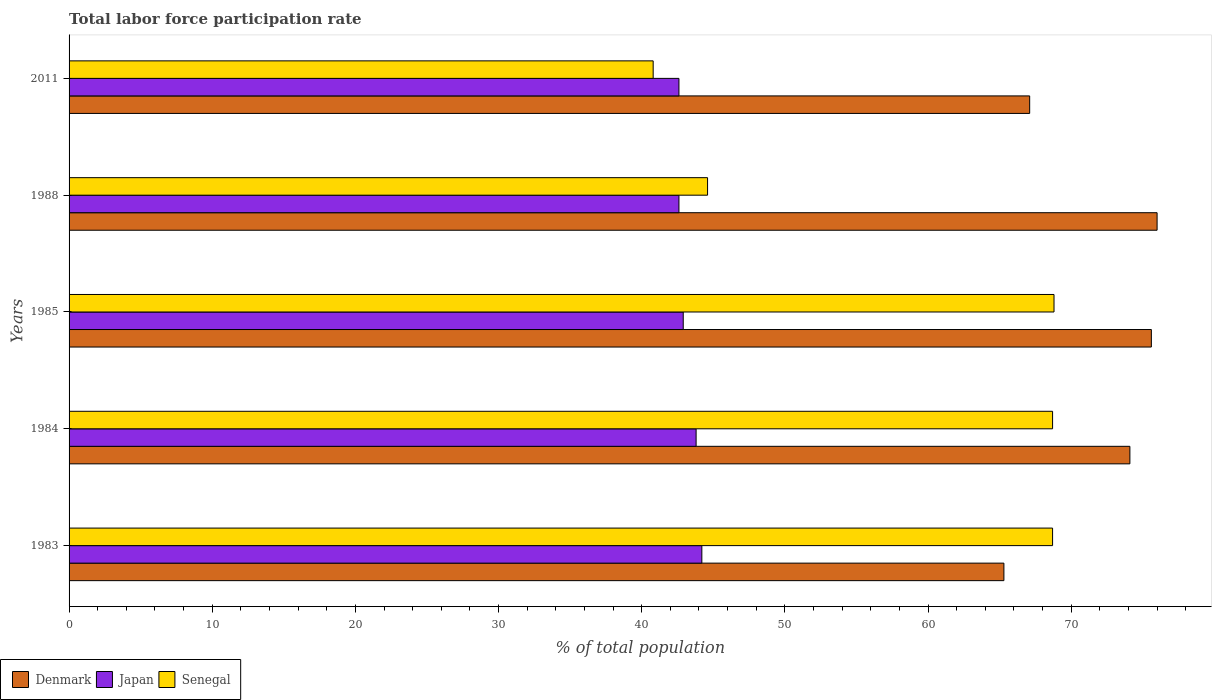How many groups of bars are there?
Your answer should be very brief. 5. Are the number of bars per tick equal to the number of legend labels?
Ensure brevity in your answer.  Yes. Are the number of bars on each tick of the Y-axis equal?
Give a very brief answer. Yes. What is the label of the 5th group of bars from the top?
Give a very brief answer. 1983. In how many cases, is the number of bars for a given year not equal to the number of legend labels?
Keep it short and to the point. 0. What is the total labor force participation rate in Japan in 1985?
Give a very brief answer. 42.9. Across all years, what is the maximum total labor force participation rate in Denmark?
Your answer should be compact. 76. Across all years, what is the minimum total labor force participation rate in Denmark?
Provide a succinct answer. 65.3. In which year was the total labor force participation rate in Japan minimum?
Provide a short and direct response. 1988. What is the total total labor force participation rate in Senegal in the graph?
Offer a terse response. 291.6. What is the difference between the total labor force participation rate in Senegal in 1984 and that in 1985?
Offer a very short reply. -0.1. What is the difference between the total labor force participation rate in Japan in 1983 and the total labor force participation rate in Denmark in 1984?
Ensure brevity in your answer.  -29.9. What is the average total labor force participation rate in Japan per year?
Provide a short and direct response. 43.22. In the year 1988, what is the difference between the total labor force participation rate in Denmark and total labor force participation rate in Japan?
Your answer should be very brief. 33.4. What is the ratio of the total labor force participation rate in Senegal in 1983 to that in 2011?
Provide a short and direct response. 1.68. Is the total labor force participation rate in Senegal in 1983 less than that in 1985?
Offer a very short reply. Yes. What is the difference between the highest and the second highest total labor force participation rate in Denmark?
Make the answer very short. 0.4. What is the difference between the highest and the lowest total labor force participation rate in Senegal?
Your response must be concise. 28. What does the 1st bar from the top in 1985 represents?
Offer a very short reply. Senegal. What does the 1st bar from the bottom in 2011 represents?
Offer a terse response. Denmark. How many years are there in the graph?
Your answer should be very brief. 5. Are the values on the major ticks of X-axis written in scientific E-notation?
Your response must be concise. No. Does the graph contain any zero values?
Offer a terse response. No. Where does the legend appear in the graph?
Keep it short and to the point. Bottom left. How are the legend labels stacked?
Offer a very short reply. Horizontal. What is the title of the graph?
Offer a very short reply. Total labor force participation rate. What is the label or title of the X-axis?
Give a very brief answer. % of total population. What is the % of total population in Denmark in 1983?
Offer a very short reply. 65.3. What is the % of total population of Japan in 1983?
Provide a short and direct response. 44.2. What is the % of total population of Senegal in 1983?
Provide a succinct answer. 68.7. What is the % of total population in Denmark in 1984?
Your answer should be very brief. 74.1. What is the % of total population in Japan in 1984?
Your response must be concise. 43.8. What is the % of total population in Senegal in 1984?
Your answer should be very brief. 68.7. What is the % of total population in Denmark in 1985?
Your response must be concise. 75.6. What is the % of total population of Japan in 1985?
Make the answer very short. 42.9. What is the % of total population of Senegal in 1985?
Ensure brevity in your answer.  68.8. What is the % of total population in Japan in 1988?
Your response must be concise. 42.6. What is the % of total population in Senegal in 1988?
Offer a terse response. 44.6. What is the % of total population in Denmark in 2011?
Offer a terse response. 67.1. What is the % of total population in Japan in 2011?
Provide a short and direct response. 42.6. What is the % of total population in Senegal in 2011?
Provide a succinct answer. 40.8. Across all years, what is the maximum % of total population in Japan?
Provide a succinct answer. 44.2. Across all years, what is the maximum % of total population of Senegal?
Provide a short and direct response. 68.8. Across all years, what is the minimum % of total population of Denmark?
Offer a terse response. 65.3. Across all years, what is the minimum % of total population of Japan?
Provide a short and direct response. 42.6. Across all years, what is the minimum % of total population of Senegal?
Offer a very short reply. 40.8. What is the total % of total population of Denmark in the graph?
Offer a terse response. 358.1. What is the total % of total population in Japan in the graph?
Keep it short and to the point. 216.1. What is the total % of total population in Senegal in the graph?
Make the answer very short. 291.6. What is the difference between the % of total population of Japan in 1983 and that in 1984?
Give a very brief answer. 0.4. What is the difference between the % of total population in Senegal in 1983 and that in 1984?
Your answer should be very brief. 0. What is the difference between the % of total population of Denmark in 1983 and that in 1985?
Offer a very short reply. -10.3. What is the difference between the % of total population in Japan in 1983 and that in 1985?
Give a very brief answer. 1.3. What is the difference between the % of total population of Senegal in 1983 and that in 1985?
Offer a terse response. -0.1. What is the difference between the % of total population in Denmark in 1983 and that in 1988?
Your answer should be very brief. -10.7. What is the difference between the % of total population of Japan in 1983 and that in 1988?
Provide a short and direct response. 1.6. What is the difference between the % of total population of Senegal in 1983 and that in 1988?
Provide a succinct answer. 24.1. What is the difference between the % of total population of Japan in 1983 and that in 2011?
Offer a very short reply. 1.6. What is the difference between the % of total population in Senegal in 1983 and that in 2011?
Provide a succinct answer. 27.9. What is the difference between the % of total population of Senegal in 1984 and that in 1988?
Make the answer very short. 24.1. What is the difference between the % of total population of Senegal in 1984 and that in 2011?
Provide a succinct answer. 27.9. What is the difference between the % of total population of Denmark in 1985 and that in 1988?
Provide a succinct answer. -0.4. What is the difference between the % of total population in Senegal in 1985 and that in 1988?
Make the answer very short. 24.2. What is the difference between the % of total population of Denmark in 1985 and that in 2011?
Your answer should be very brief. 8.5. What is the difference between the % of total population in Senegal in 1985 and that in 2011?
Ensure brevity in your answer.  28. What is the difference between the % of total population in Senegal in 1988 and that in 2011?
Provide a short and direct response. 3.8. What is the difference between the % of total population of Denmark in 1983 and the % of total population of Senegal in 1984?
Offer a very short reply. -3.4. What is the difference between the % of total population of Japan in 1983 and the % of total population of Senegal in 1984?
Your response must be concise. -24.5. What is the difference between the % of total population in Denmark in 1983 and the % of total population in Japan in 1985?
Give a very brief answer. 22.4. What is the difference between the % of total population in Japan in 1983 and the % of total population in Senegal in 1985?
Your answer should be compact. -24.6. What is the difference between the % of total population in Denmark in 1983 and the % of total population in Japan in 1988?
Ensure brevity in your answer.  22.7. What is the difference between the % of total population of Denmark in 1983 and the % of total population of Senegal in 1988?
Give a very brief answer. 20.7. What is the difference between the % of total population in Denmark in 1983 and the % of total population in Japan in 2011?
Offer a very short reply. 22.7. What is the difference between the % of total population of Denmark in 1984 and the % of total population of Japan in 1985?
Provide a succinct answer. 31.2. What is the difference between the % of total population in Denmark in 1984 and the % of total population in Senegal in 1985?
Keep it short and to the point. 5.3. What is the difference between the % of total population of Japan in 1984 and the % of total population of Senegal in 1985?
Keep it short and to the point. -25. What is the difference between the % of total population of Denmark in 1984 and the % of total population of Japan in 1988?
Provide a succinct answer. 31.5. What is the difference between the % of total population in Denmark in 1984 and the % of total population in Senegal in 1988?
Your response must be concise. 29.5. What is the difference between the % of total population in Japan in 1984 and the % of total population in Senegal in 1988?
Offer a very short reply. -0.8. What is the difference between the % of total population of Denmark in 1984 and the % of total population of Japan in 2011?
Ensure brevity in your answer.  31.5. What is the difference between the % of total population in Denmark in 1984 and the % of total population in Senegal in 2011?
Keep it short and to the point. 33.3. What is the difference between the % of total population of Japan in 1984 and the % of total population of Senegal in 2011?
Your answer should be compact. 3. What is the difference between the % of total population in Denmark in 1985 and the % of total population in Japan in 1988?
Your answer should be compact. 33. What is the difference between the % of total population in Denmark in 1985 and the % of total population in Senegal in 2011?
Offer a very short reply. 34.8. What is the difference between the % of total population in Denmark in 1988 and the % of total population in Japan in 2011?
Provide a short and direct response. 33.4. What is the difference between the % of total population in Denmark in 1988 and the % of total population in Senegal in 2011?
Your response must be concise. 35.2. What is the average % of total population of Denmark per year?
Your answer should be compact. 71.62. What is the average % of total population of Japan per year?
Give a very brief answer. 43.22. What is the average % of total population of Senegal per year?
Make the answer very short. 58.32. In the year 1983, what is the difference between the % of total population in Denmark and % of total population in Japan?
Your answer should be compact. 21.1. In the year 1983, what is the difference between the % of total population in Japan and % of total population in Senegal?
Offer a very short reply. -24.5. In the year 1984, what is the difference between the % of total population of Denmark and % of total population of Japan?
Your response must be concise. 30.3. In the year 1984, what is the difference between the % of total population of Denmark and % of total population of Senegal?
Provide a succinct answer. 5.4. In the year 1984, what is the difference between the % of total population in Japan and % of total population in Senegal?
Ensure brevity in your answer.  -24.9. In the year 1985, what is the difference between the % of total population in Denmark and % of total population in Japan?
Offer a terse response. 32.7. In the year 1985, what is the difference between the % of total population in Denmark and % of total population in Senegal?
Ensure brevity in your answer.  6.8. In the year 1985, what is the difference between the % of total population in Japan and % of total population in Senegal?
Make the answer very short. -25.9. In the year 1988, what is the difference between the % of total population of Denmark and % of total population of Japan?
Offer a very short reply. 33.4. In the year 1988, what is the difference between the % of total population of Denmark and % of total population of Senegal?
Provide a succinct answer. 31.4. In the year 2011, what is the difference between the % of total population in Denmark and % of total population in Senegal?
Your answer should be very brief. 26.3. In the year 2011, what is the difference between the % of total population in Japan and % of total population in Senegal?
Ensure brevity in your answer.  1.8. What is the ratio of the % of total population of Denmark in 1983 to that in 1984?
Provide a short and direct response. 0.88. What is the ratio of the % of total population of Japan in 1983 to that in 1984?
Offer a terse response. 1.01. What is the ratio of the % of total population of Senegal in 1983 to that in 1984?
Your response must be concise. 1. What is the ratio of the % of total population of Denmark in 1983 to that in 1985?
Your answer should be very brief. 0.86. What is the ratio of the % of total population of Japan in 1983 to that in 1985?
Give a very brief answer. 1.03. What is the ratio of the % of total population of Senegal in 1983 to that in 1985?
Ensure brevity in your answer.  1. What is the ratio of the % of total population of Denmark in 1983 to that in 1988?
Ensure brevity in your answer.  0.86. What is the ratio of the % of total population in Japan in 1983 to that in 1988?
Your answer should be compact. 1.04. What is the ratio of the % of total population of Senegal in 1983 to that in 1988?
Provide a succinct answer. 1.54. What is the ratio of the % of total population of Denmark in 1983 to that in 2011?
Your answer should be very brief. 0.97. What is the ratio of the % of total population of Japan in 1983 to that in 2011?
Offer a terse response. 1.04. What is the ratio of the % of total population in Senegal in 1983 to that in 2011?
Your answer should be compact. 1.68. What is the ratio of the % of total population in Denmark in 1984 to that in 1985?
Provide a short and direct response. 0.98. What is the ratio of the % of total population of Japan in 1984 to that in 1988?
Offer a very short reply. 1.03. What is the ratio of the % of total population in Senegal in 1984 to that in 1988?
Provide a short and direct response. 1.54. What is the ratio of the % of total population in Denmark in 1984 to that in 2011?
Keep it short and to the point. 1.1. What is the ratio of the % of total population in Japan in 1984 to that in 2011?
Offer a terse response. 1.03. What is the ratio of the % of total population in Senegal in 1984 to that in 2011?
Offer a terse response. 1.68. What is the ratio of the % of total population in Denmark in 1985 to that in 1988?
Provide a short and direct response. 0.99. What is the ratio of the % of total population in Senegal in 1985 to that in 1988?
Your answer should be compact. 1.54. What is the ratio of the % of total population in Denmark in 1985 to that in 2011?
Offer a terse response. 1.13. What is the ratio of the % of total population in Senegal in 1985 to that in 2011?
Offer a very short reply. 1.69. What is the ratio of the % of total population in Denmark in 1988 to that in 2011?
Make the answer very short. 1.13. What is the ratio of the % of total population in Senegal in 1988 to that in 2011?
Make the answer very short. 1.09. What is the difference between the highest and the lowest % of total population in Denmark?
Provide a short and direct response. 10.7. What is the difference between the highest and the lowest % of total population in Senegal?
Your response must be concise. 28. 